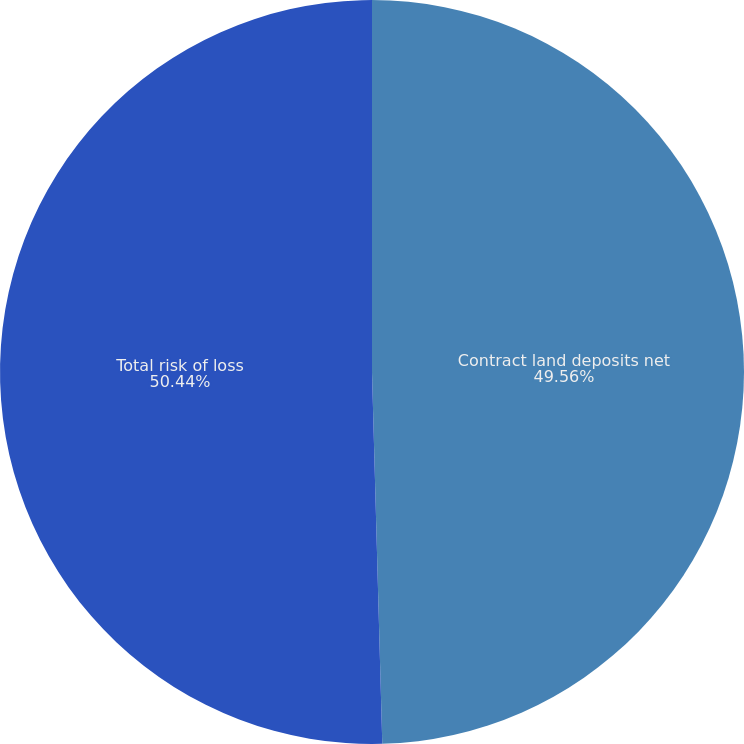<chart> <loc_0><loc_0><loc_500><loc_500><pie_chart><fcel>Contract land deposits net<fcel>Total risk of loss<nl><fcel>49.56%<fcel>50.44%<nl></chart> 